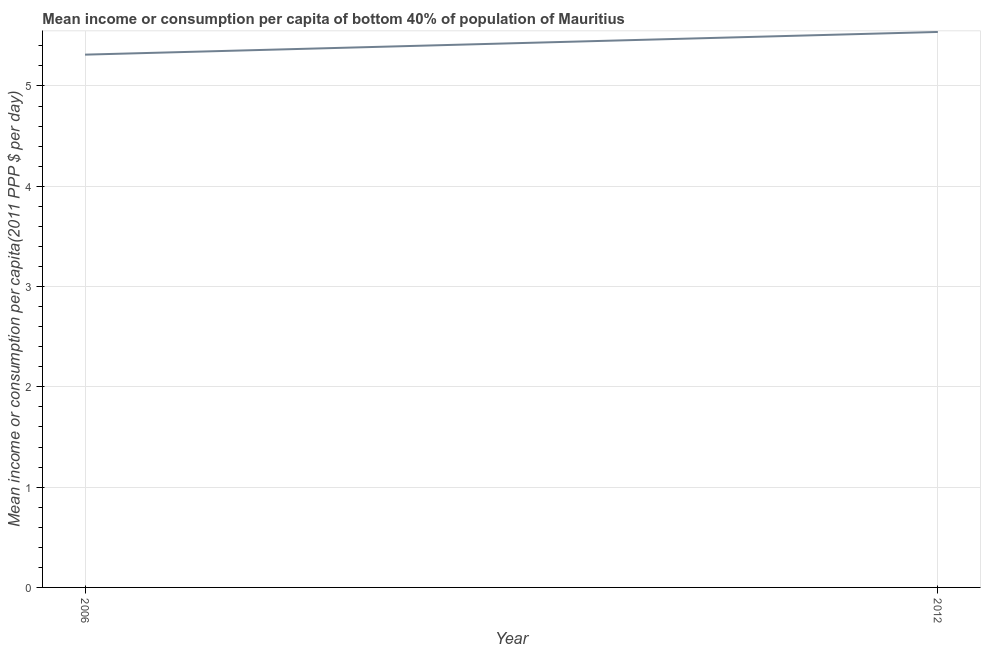What is the mean income or consumption in 2012?
Ensure brevity in your answer.  5.54. Across all years, what is the maximum mean income or consumption?
Provide a succinct answer. 5.54. Across all years, what is the minimum mean income or consumption?
Your answer should be very brief. 5.31. In which year was the mean income or consumption maximum?
Your answer should be compact. 2012. What is the sum of the mean income or consumption?
Offer a very short reply. 10.85. What is the difference between the mean income or consumption in 2006 and 2012?
Make the answer very short. -0.23. What is the average mean income or consumption per year?
Provide a short and direct response. 5.43. What is the median mean income or consumption?
Offer a very short reply. 5.43. What is the ratio of the mean income or consumption in 2006 to that in 2012?
Your answer should be very brief. 0.96. Does the graph contain any zero values?
Give a very brief answer. No. Does the graph contain grids?
Give a very brief answer. Yes. What is the title of the graph?
Give a very brief answer. Mean income or consumption per capita of bottom 40% of population of Mauritius. What is the label or title of the X-axis?
Offer a terse response. Year. What is the label or title of the Y-axis?
Your answer should be very brief. Mean income or consumption per capita(2011 PPP $ per day). What is the Mean income or consumption per capita(2011 PPP $ per day) of 2006?
Offer a very short reply. 5.31. What is the Mean income or consumption per capita(2011 PPP $ per day) in 2012?
Offer a terse response. 5.54. What is the difference between the Mean income or consumption per capita(2011 PPP $ per day) in 2006 and 2012?
Provide a succinct answer. -0.23. 